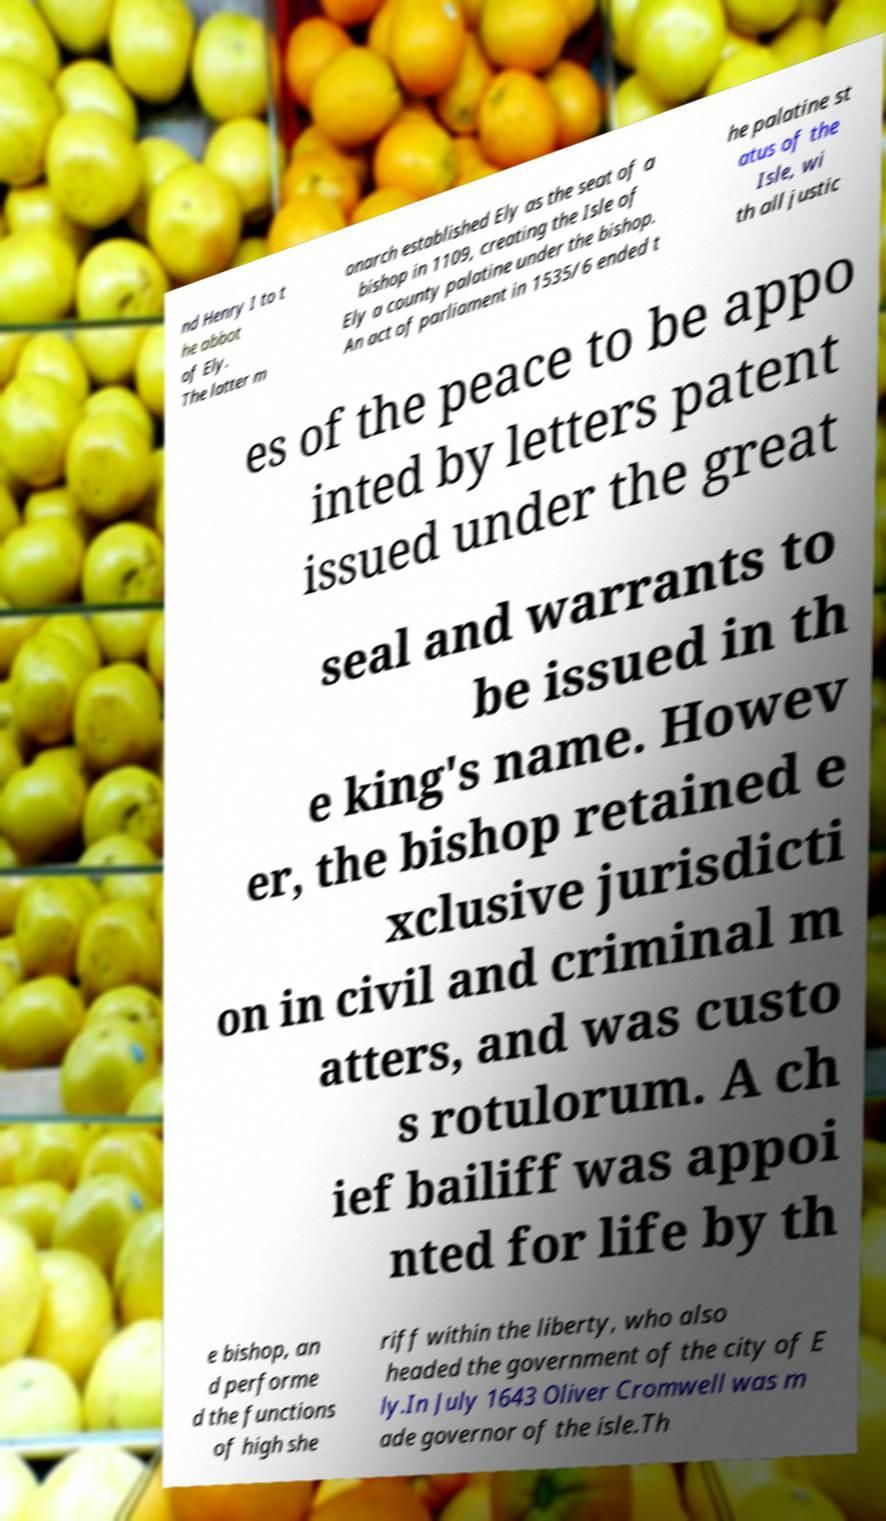For documentation purposes, I need the text within this image transcribed. Could you provide that? nd Henry I to t he abbot of Ely. The latter m onarch established Ely as the seat of a bishop in 1109, creating the Isle of Ely a county palatine under the bishop. An act of parliament in 1535/6 ended t he palatine st atus of the Isle, wi th all justic es of the peace to be appo inted by letters patent issued under the great seal and warrants to be issued in th e king's name. Howev er, the bishop retained e xclusive jurisdicti on in civil and criminal m atters, and was custo s rotulorum. A ch ief bailiff was appoi nted for life by th e bishop, an d performe d the functions of high she riff within the liberty, who also headed the government of the city of E ly.In July 1643 Oliver Cromwell was m ade governor of the isle.Th 